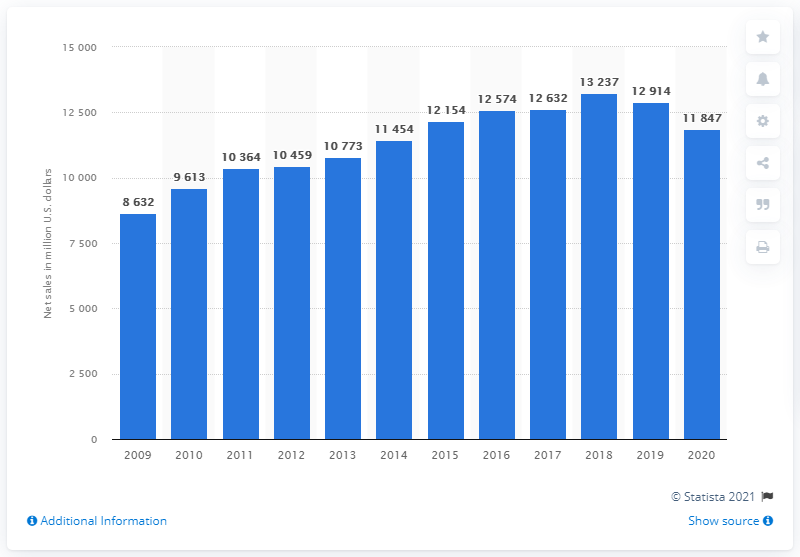Point out several critical features in this image. In 2020, Limited Brands' global net sales were $118,470. 